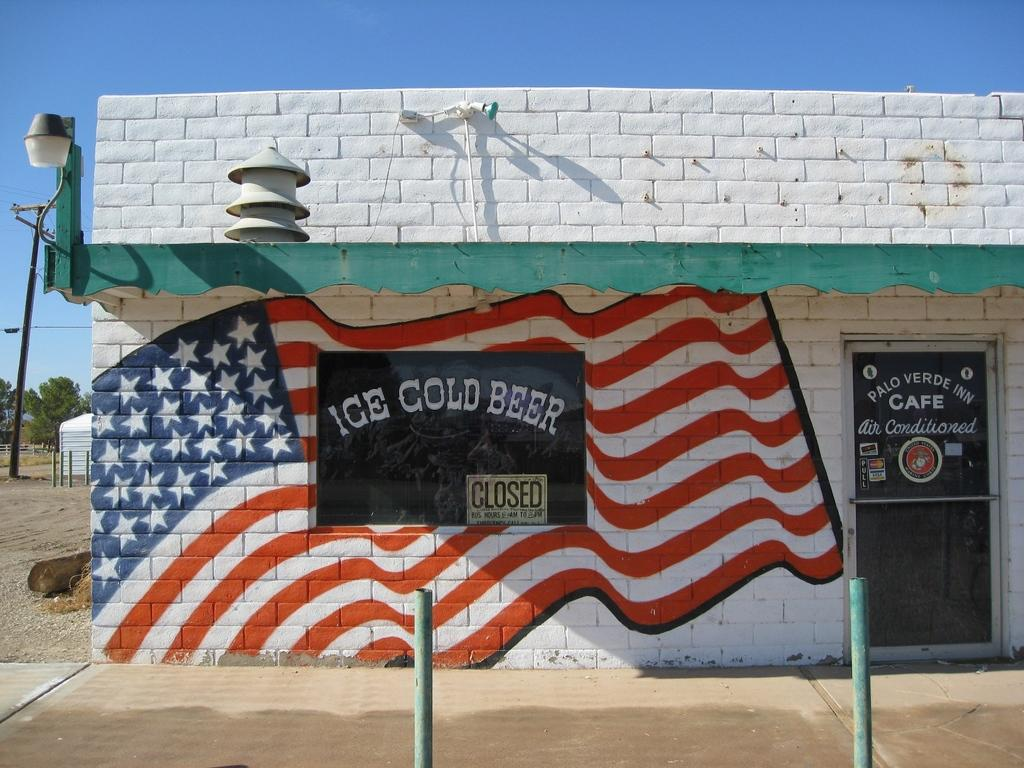What objects can be seen in the image that resemble long, vertical structures? There are poles in the image. What type of artwork is depicted in the image? There is a painting of a flag in the image. What feature of a building is present in the image? There is a door in the image. What type of illumination is present in the image? There are lights in the image. What type of natural scenery is visible in the background of the image? There are trees in the background of the image. What other object can be seen in the background of the image? There is a pole in the background of the image. What can be seen in the sky in the background of the image? The sky is visible in the background of the image, and it is blue in color. Where is the drawer located in the image? There is no drawer present in the image. What nation is represented by the flag in the image? The image only shows a painting of a flag, but it does not specify which nation it represents. 